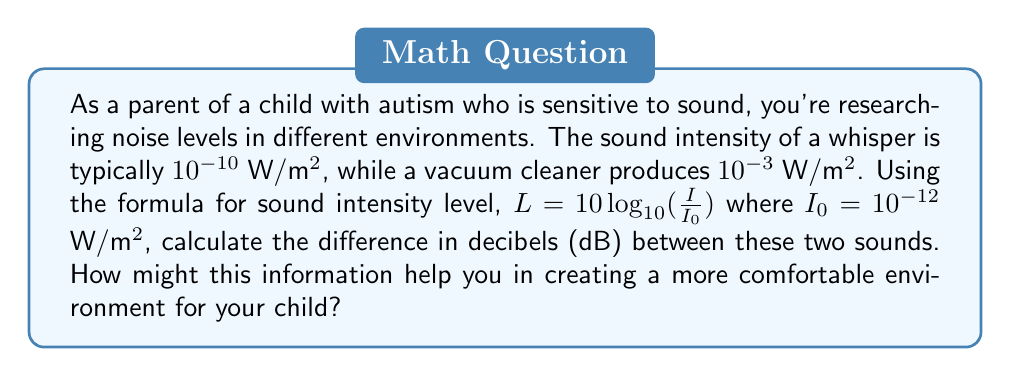Could you help me with this problem? Let's approach this step-by-step:

1) We'll use the formula $L = 10 \log_{10}(\frac{I}{I_0})$ where $I_0 = 10^{-12}$ W/m².

2) For the whisper:
   $L_{whisper} = 10 \log_{10}(\frac{10^{-10}}{10^{-12}})$
   $= 10 \log_{10}(10^2) = 10 \cdot 2 = 20$ dB

3) For the vacuum cleaner:
   $L_{vacuum} = 10 \log_{10}(\frac{10^{-3}}{10^{-12}})$
   $= 10 \log_{10}(10^9) = 10 \cdot 9 = 90$ dB

4) The difference in decibels:
   $90$ dB $- 20$ dB $= 70$ dB

This significant difference illustrates why a vacuum cleaner might be particularly distressing for a child with autism who is sensitive to sound. Understanding these levels can help in creating strategies to minimize exposure to louder sounds or in preparing the child for potentially uncomfortable noise levels.
Answer: 70 dB 